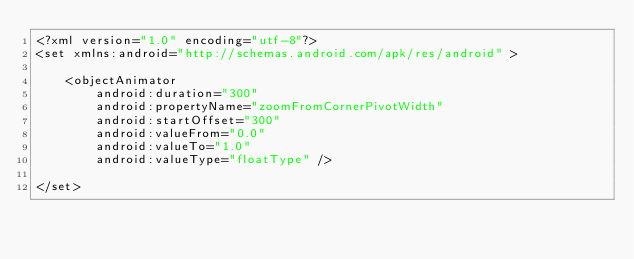<code> <loc_0><loc_0><loc_500><loc_500><_XML_><?xml version="1.0" encoding="utf-8"?>
<set xmlns:android="http://schemas.android.com/apk/res/android" >

    <objectAnimator
        android:duration="300"
        android:propertyName="zoomFromCornerPivotWidth"
        android:startOffset="300"
        android:valueFrom="0.0"
        android:valueTo="1.0"
        android:valueType="floatType" />
    
</set></code> 